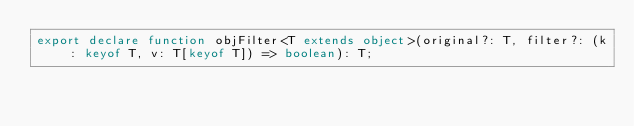Convert code to text. <code><loc_0><loc_0><loc_500><loc_500><_TypeScript_>export declare function objFilter<T extends object>(original?: T, filter?: (k: keyof T, v: T[keyof T]) => boolean): T;
</code> 